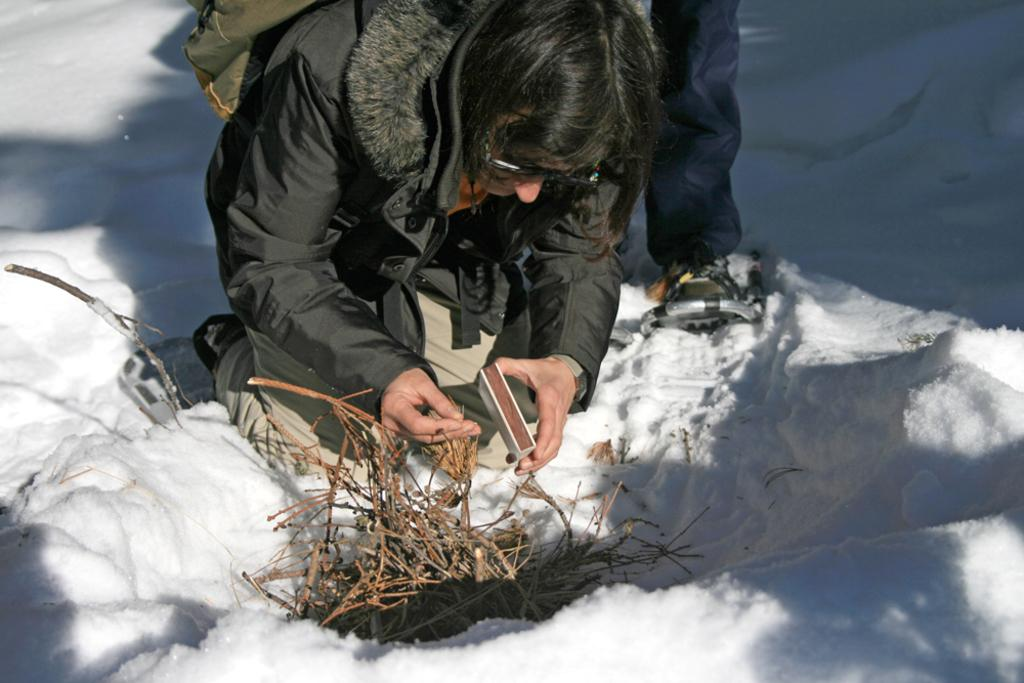Who is the main subject in the image? There is a woman in the image. What is the woman doing in the image? The woman is trying to light a fire. What is the woman wearing in the image? The woman is wearing a coat. What is the weather like in the image? The image depicts snow, indicating cold weather. How many pigs are present in the image? There are no pigs present in the image. What type of development is taking place in the image? There is no development or construction activity depicted in the image. 